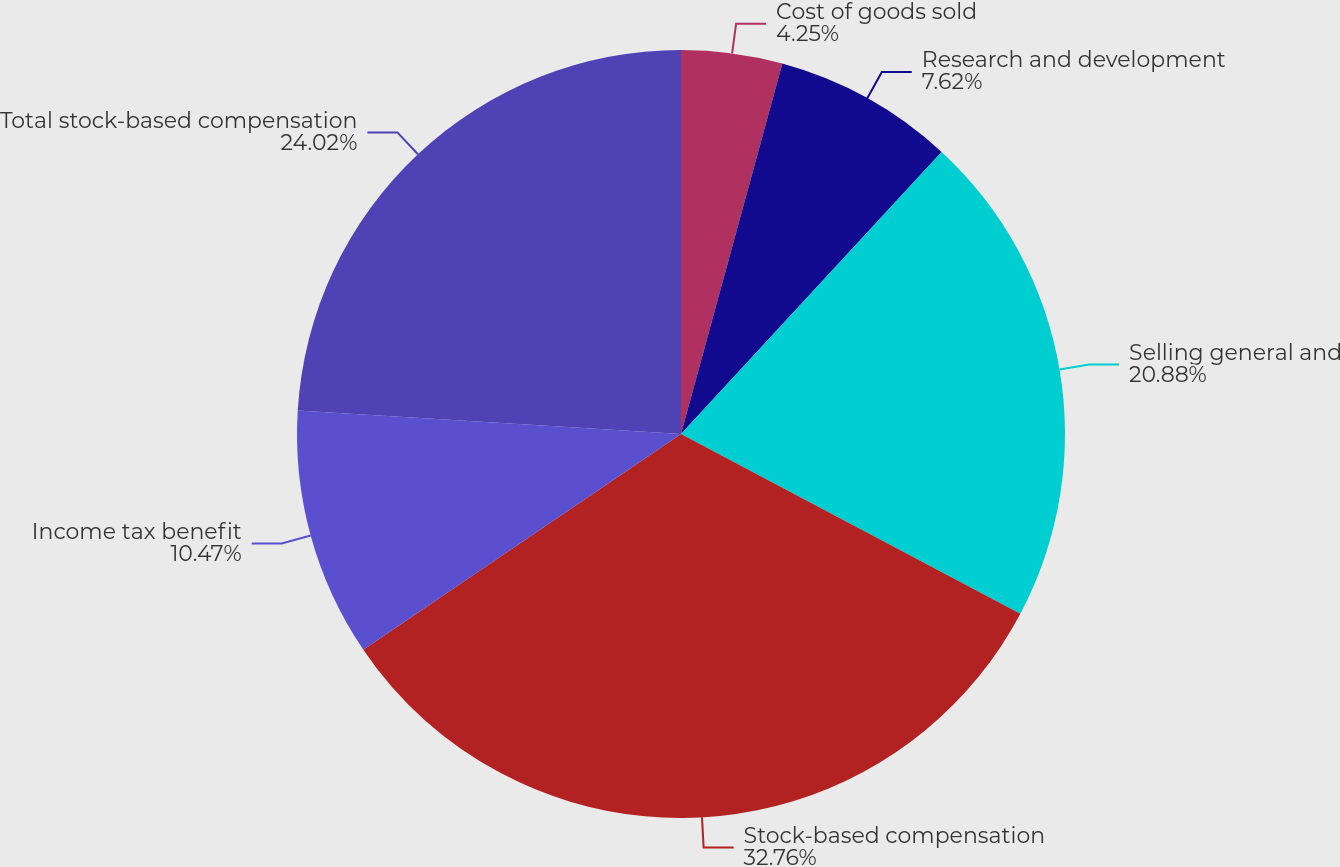<chart> <loc_0><loc_0><loc_500><loc_500><pie_chart><fcel>Cost of goods sold<fcel>Research and development<fcel>Selling general and<fcel>Stock-based compensation<fcel>Income tax benefit<fcel>Total stock-based compensation<nl><fcel>4.25%<fcel>7.62%<fcel>20.88%<fcel>32.75%<fcel>10.47%<fcel>24.02%<nl></chart> 